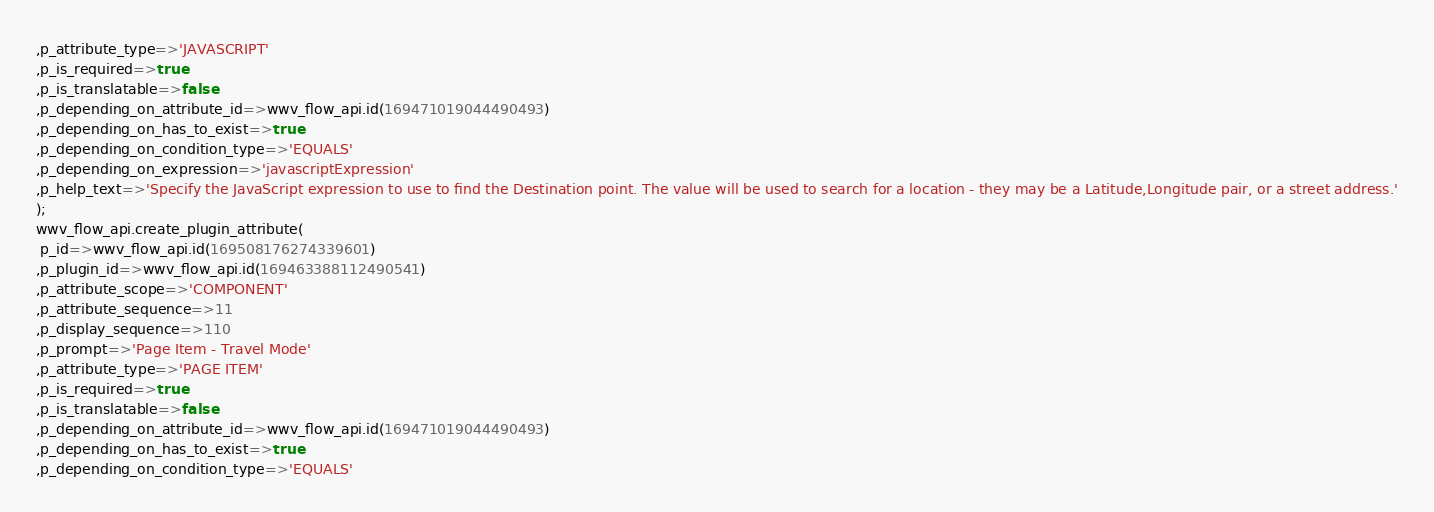<code> <loc_0><loc_0><loc_500><loc_500><_SQL_>,p_attribute_type=>'JAVASCRIPT'
,p_is_required=>true
,p_is_translatable=>false
,p_depending_on_attribute_id=>wwv_flow_api.id(169471019044490493)
,p_depending_on_has_to_exist=>true
,p_depending_on_condition_type=>'EQUALS'
,p_depending_on_expression=>'javascriptExpression'
,p_help_text=>'Specify the JavaScript expression to use to find the Destination point. The value will be used to search for a location - they may be a Latitude,Longitude pair, or a street address.'
);
wwv_flow_api.create_plugin_attribute(
 p_id=>wwv_flow_api.id(169508176274339601)
,p_plugin_id=>wwv_flow_api.id(169463388112490541)
,p_attribute_scope=>'COMPONENT'
,p_attribute_sequence=>11
,p_display_sequence=>110
,p_prompt=>'Page Item - Travel Mode'
,p_attribute_type=>'PAGE ITEM'
,p_is_required=>true
,p_is_translatable=>false
,p_depending_on_attribute_id=>wwv_flow_api.id(169471019044490493)
,p_depending_on_has_to_exist=>true
,p_depending_on_condition_type=>'EQUALS'</code> 